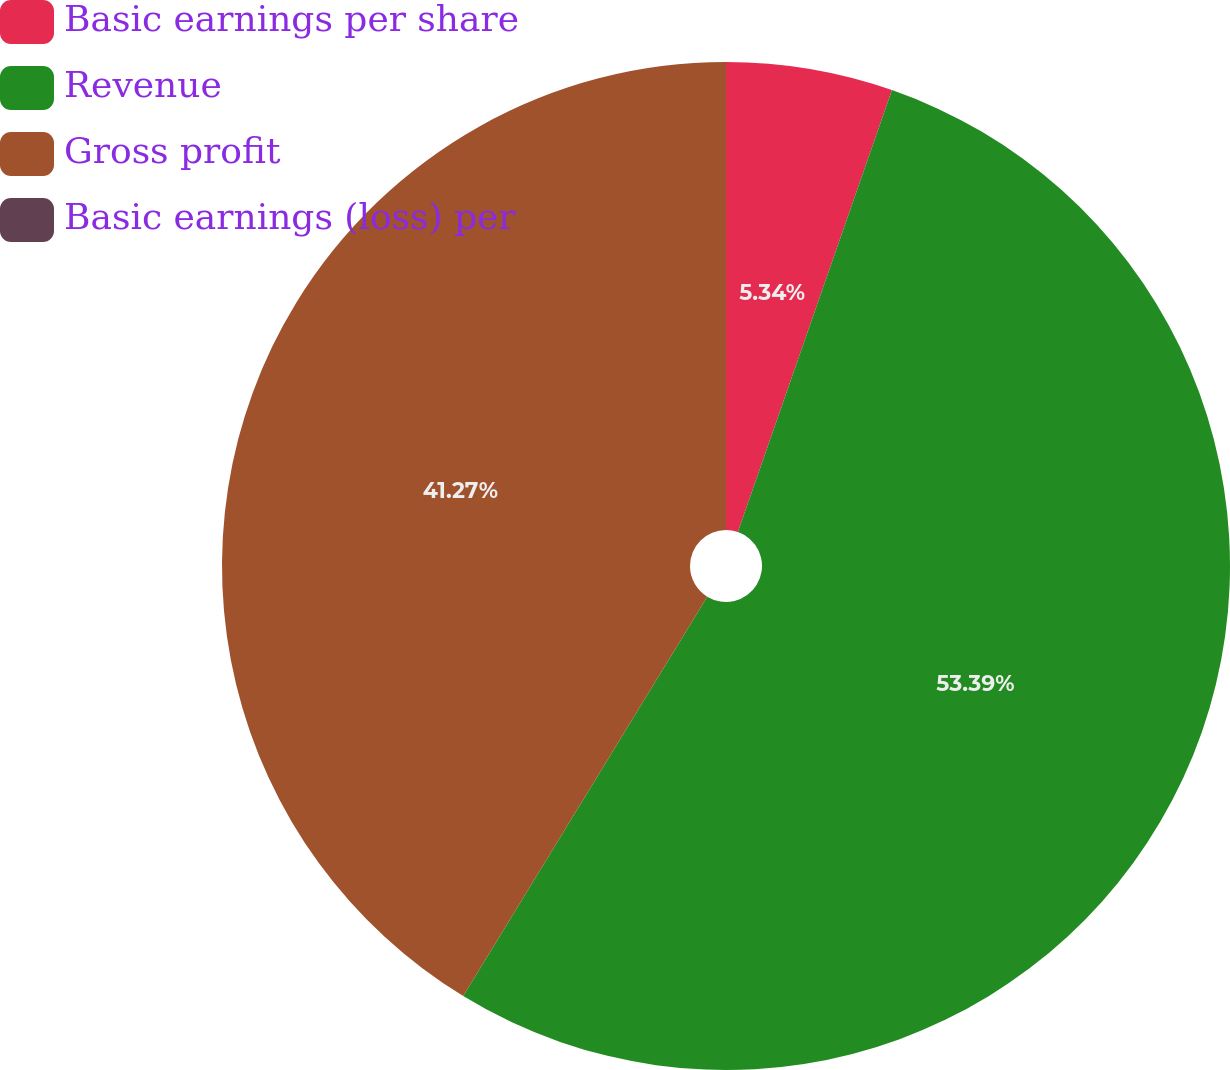<chart> <loc_0><loc_0><loc_500><loc_500><pie_chart><fcel>Basic earnings per share<fcel>Revenue<fcel>Gross profit<fcel>Basic earnings (loss) per<nl><fcel>5.34%<fcel>53.39%<fcel>41.27%<fcel>0.0%<nl></chart> 